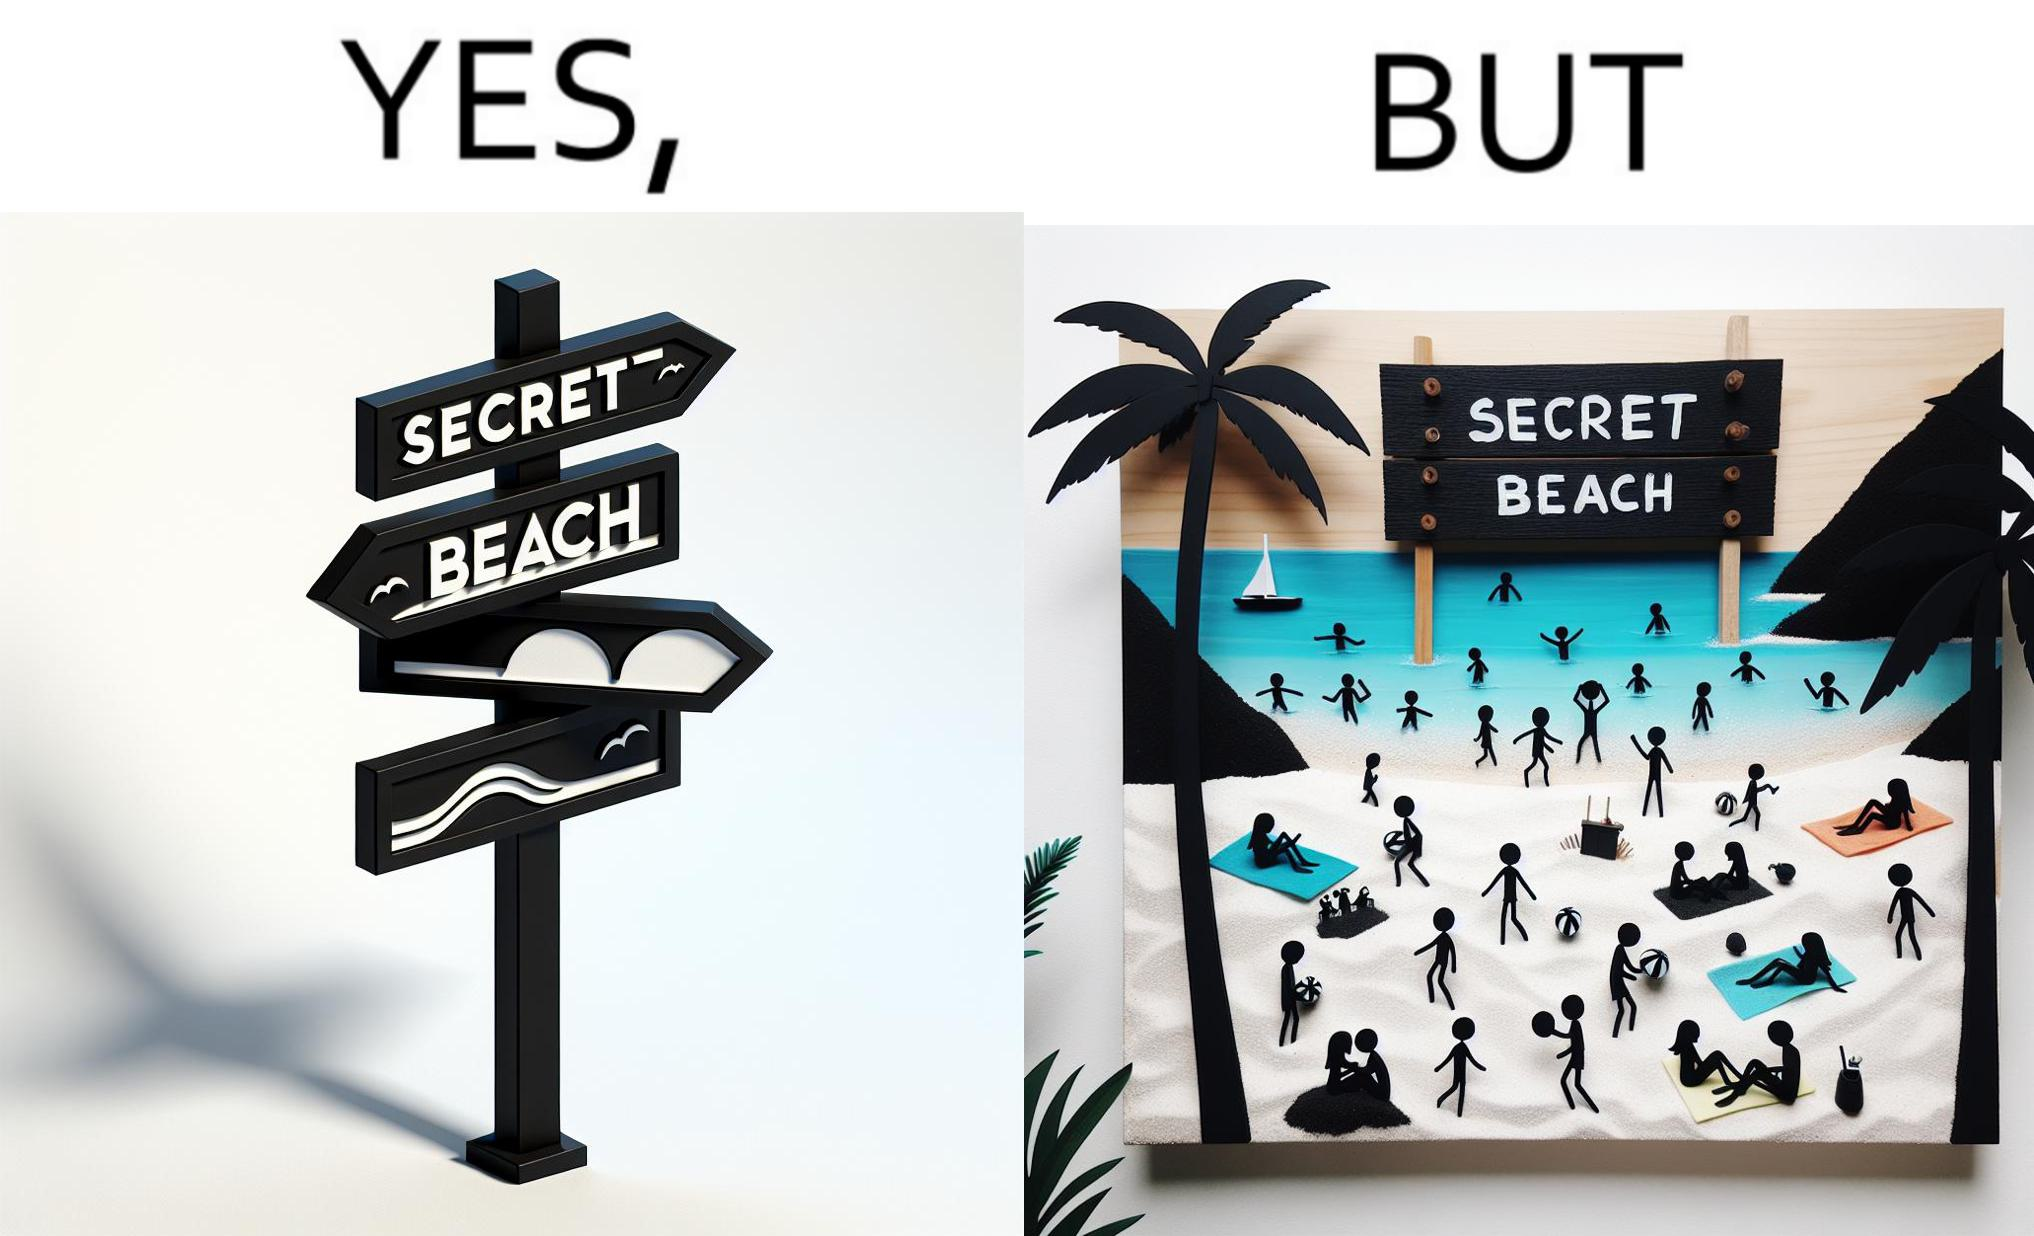Why is this image considered satirical? The image is ironical, as people can be seen in the beach, and is clearly not a secret, while the board at the entrance has "Secret Beach" written on it. 